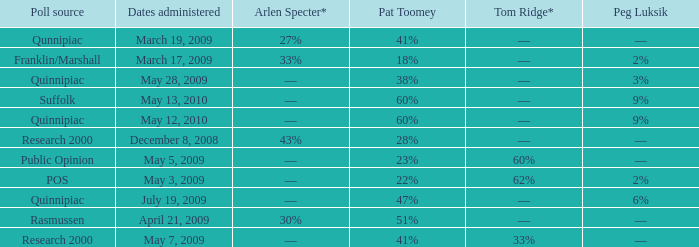Which Tom Ridge* has a Poll source of research 2000, and an Arlen Specter* of 43%? ––. 